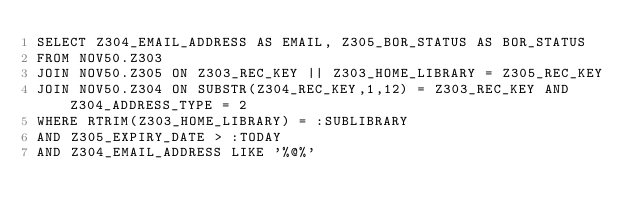<code> <loc_0><loc_0><loc_500><loc_500><_SQL_>SELECT Z304_EMAIL_ADDRESS AS EMAIL, Z305_BOR_STATUS AS BOR_STATUS
FROM NOV50.Z303
JOIN NOV50.Z305 ON Z303_REC_KEY || Z303_HOME_LIBRARY = Z305_REC_KEY
JOIN NOV50.Z304 ON SUBSTR(Z304_REC_KEY,1,12) = Z303_REC_KEY AND Z304_ADDRESS_TYPE = 2
WHERE RTRIM(Z303_HOME_LIBRARY) = :SUBLIBRARY
AND Z305_EXPIRY_DATE > :TODAY
AND Z304_EMAIL_ADDRESS LIKE '%@%'
</code> 